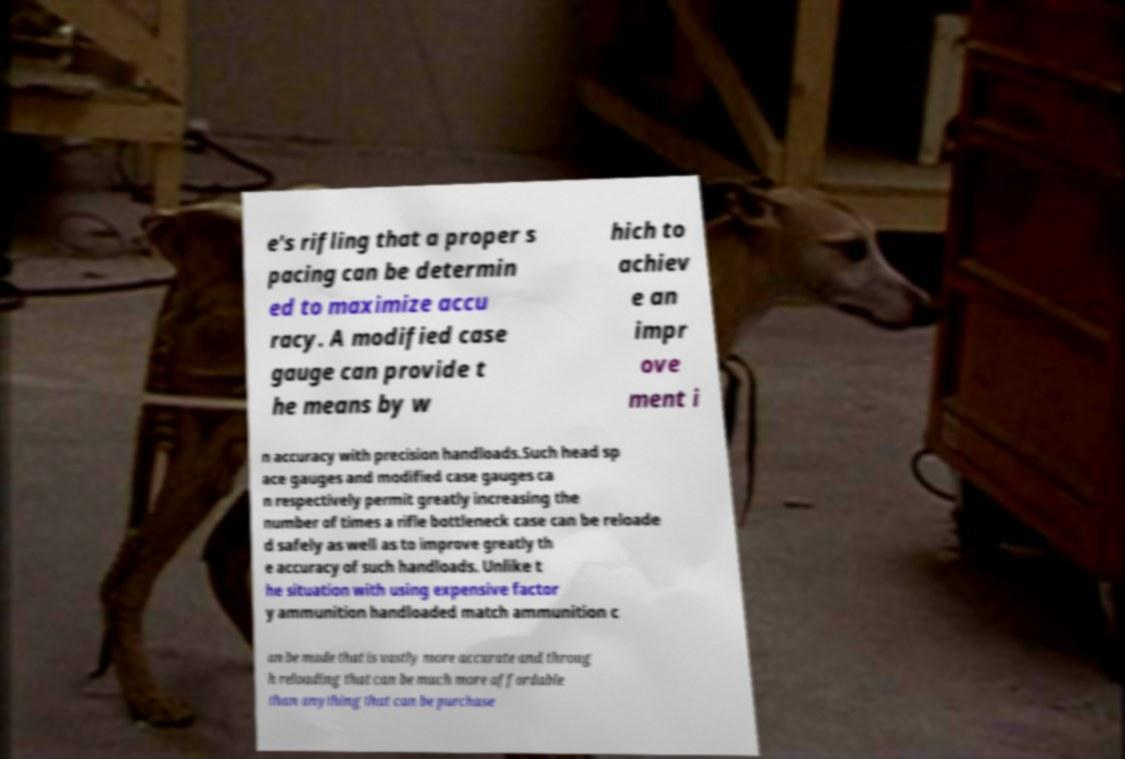What messages or text are displayed in this image? I need them in a readable, typed format. e's rifling that a proper s pacing can be determin ed to maximize accu racy. A modified case gauge can provide t he means by w hich to achiev e an impr ove ment i n accuracy with precision handloads.Such head sp ace gauges and modified case gauges ca n respectively permit greatly increasing the number of times a rifle bottleneck case can be reloade d safely as well as to improve greatly th e accuracy of such handloads. Unlike t he situation with using expensive factor y ammunition handloaded match ammunition c an be made that is vastly more accurate and throug h reloading that can be much more affordable than anything that can be purchase 